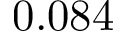<formula> <loc_0><loc_0><loc_500><loc_500>0 . 0 8 4</formula> 